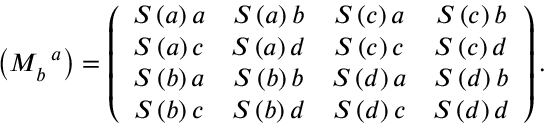<formula> <loc_0><loc_0><loc_500><loc_500>\left ( M _ { b } ^ { \, a } \right ) = \left ( \begin{array} { c c c c } { S \left ( a \right ) a } & { S \left ( a \right ) b } & { S \left ( c \right ) a } & { S \left ( c \right ) b } \\ { S \left ( a \right ) c } & { S \left ( a \right ) d } & { S \left ( c \right ) c } & { S \left ( c \right ) d } \\ { S \left ( b \right ) a } & { S \left ( b \right ) b } & { S \left ( d \right ) a } & { S \left ( d \right ) b } \\ { S \left ( b \right ) c } & { S \left ( b \right ) d } & { S \left ( d \right ) c } & { S \left ( d \right ) d } \end{array} \right ) .</formula> 